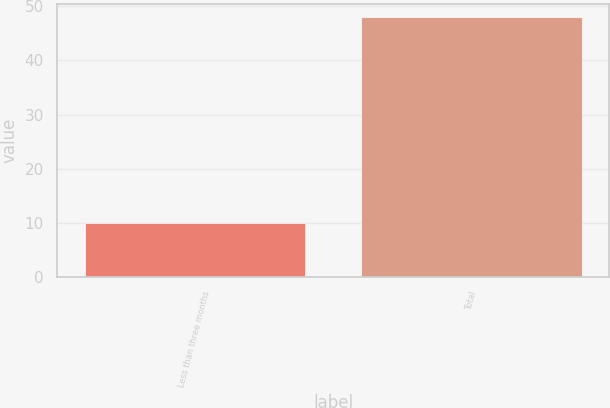Convert chart to OTSL. <chart><loc_0><loc_0><loc_500><loc_500><bar_chart><fcel>Less than three months<fcel>Total<nl><fcel>10<fcel>48<nl></chart> 